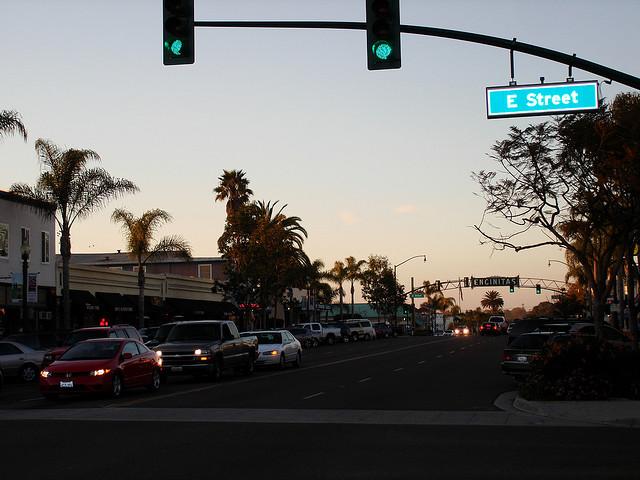Does the light signal go or stop?
Keep it brief. Go. How many traffic lights are in this street?
Quick response, please. 4. Is it day or night?
Quick response, please. Day. How many cars are on the road?
Concise answer only. 6. What is the name of the street?
Keep it brief. E street. Is the sun setting?
Concise answer only. Yes. What color is the stop light?
Quick response, please. Green. What color is lit on the traffic lights?
Be succinct. Green. What does the green sign say?
Short answer required. E street. How many street lights are visible?
Be succinct. 4. How many sets of traffic lights can be seen?
Concise answer only. 2. What color is the stop light currently?
Answer briefly. Green. What does the sign say?
Concise answer only. E street. What store is in the background?
Concise answer only. None. What does the light indicate?
Short answer required. Go. What kind of trees are in the scene?
Give a very brief answer. Palm. What road is the cross street?
Answer briefly. E street. Is the sky overcast?
Short answer required. No. 